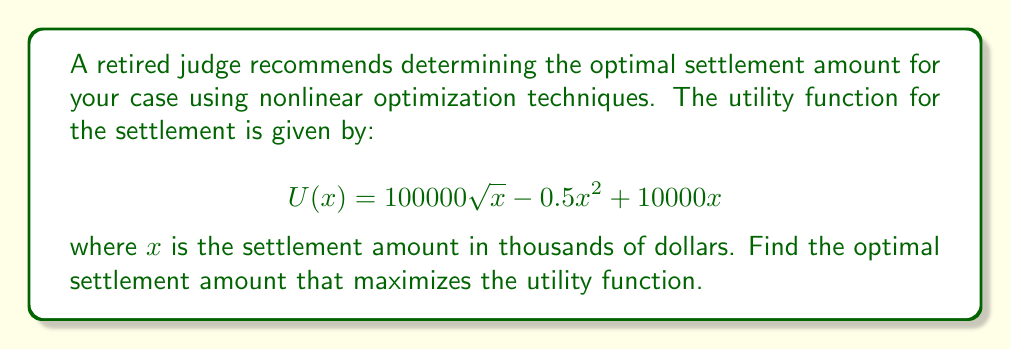Give your solution to this math problem. To find the optimal settlement amount, we need to maximize the utility function $U(x)$. This can be done by finding the critical point where the derivative of $U(x)$ equals zero.

Step 1: Calculate the derivative of $U(x)$
$$U'(x) = \frac{50000}{\sqrt{x}} - x + 10000$$

Step 2: Set the derivative equal to zero and solve for x
$$\frac{50000}{\sqrt{x}} - x + 10000 = 0$$

Step 3: Multiply both sides by $\sqrt{x}$
$$50000 - x\sqrt{x} + 10000\sqrt{x} = 0$$

Step 4: Let $y = \sqrt{x}$, then $x = y^2$
$$50000 - y^3 + 10000y = 0$$

Step 5: Rearrange the equation
$$y^3 - 10000y - 50000 = 0$$

Step 6: This cubic equation can be solved using numerical methods. Using a computer algebra system or calculator, we find that the only real solution is approximately:

$$y \approx 23.9037$$

Step 7: Since $y = \sqrt{x}$, we can find x by squaring y
$$x = y^2 \approx 23.9037^2 \approx 571.3868$$

Step 8: Verify that this is indeed a maximum by checking the second derivative
$$U''(x) = -\frac{25000}{x^{3/2}} - 1$$

At $x \approx 571.3868$, $U''(x) < 0$, confirming that this is a maximum.

Therefore, the optimal settlement amount is approximately 571,387 dollars.
Answer: $571,387 